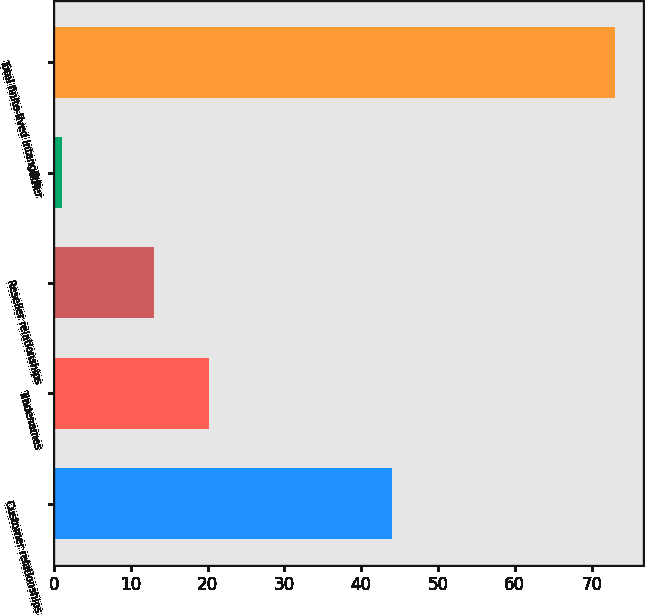<chart> <loc_0><loc_0><loc_500><loc_500><bar_chart><fcel>Customer relationships<fcel>Tradenames<fcel>Reseller relationships<fcel>Other<fcel>Total finite-lived intangible<nl><fcel>44<fcel>20.2<fcel>13<fcel>1<fcel>73<nl></chart> 